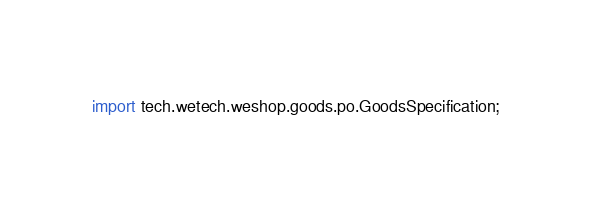Convert code to text. <code><loc_0><loc_0><loc_500><loc_500><_Java_>import tech.wetech.weshop.goods.po.GoodsSpecification;</code> 